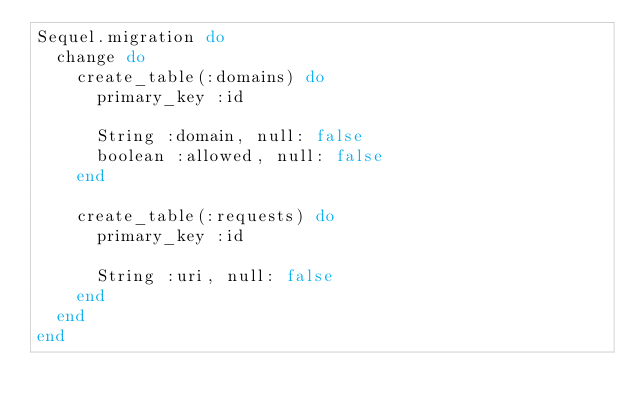<code> <loc_0><loc_0><loc_500><loc_500><_Ruby_>Sequel.migration do
  change do
    create_table(:domains) do
      primary_key :id
      
      String :domain, null: false
      boolean :allowed, null: false
    end

    create_table(:requests) do
      primary_key :id

      String :uri, null: false
    end
  end
end
</code> 